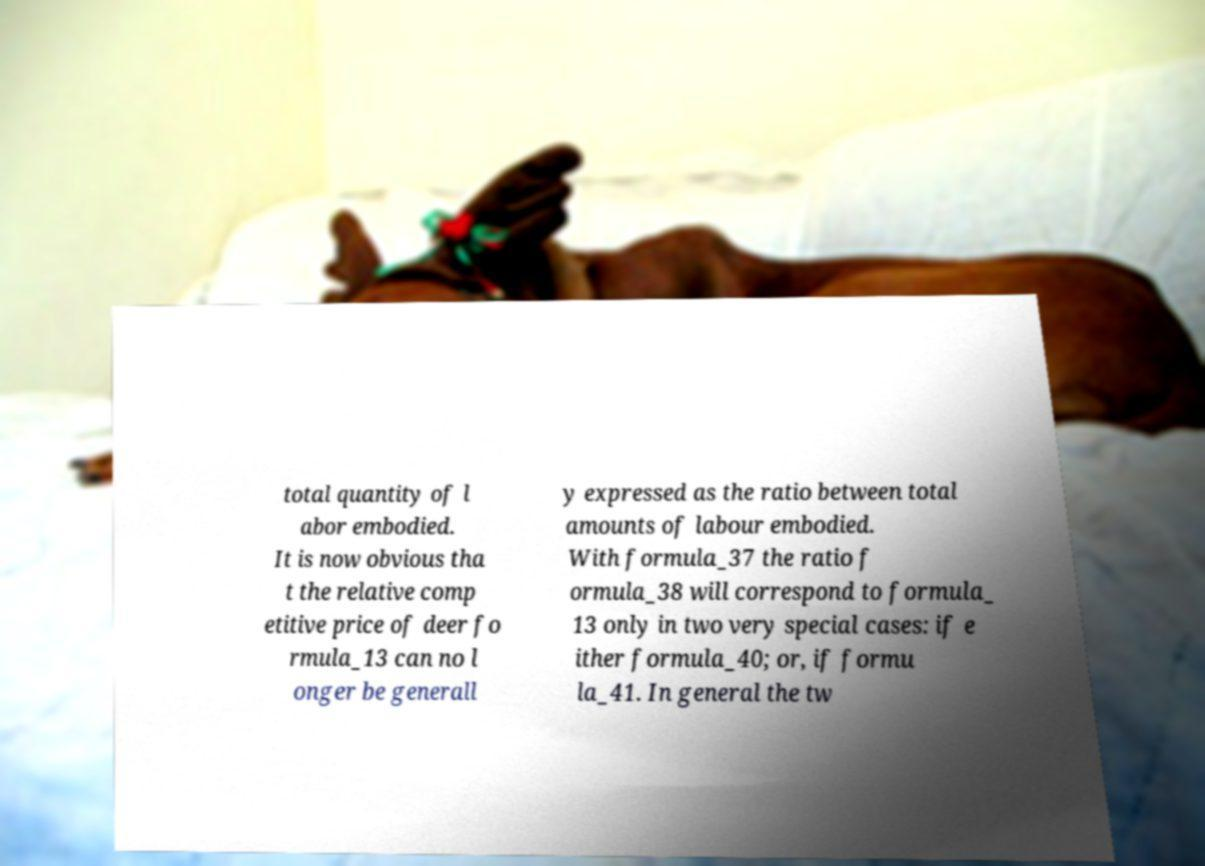Can you accurately transcribe the text from the provided image for me? total quantity of l abor embodied. It is now obvious tha t the relative comp etitive price of deer fo rmula_13 can no l onger be generall y expressed as the ratio between total amounts of labour embodied. With formula_37 the ratio f ormula_38 will correspond to formula_ 13 only in two very special cases: if e ither formula_40; or, if formu la_41. In general the tw 